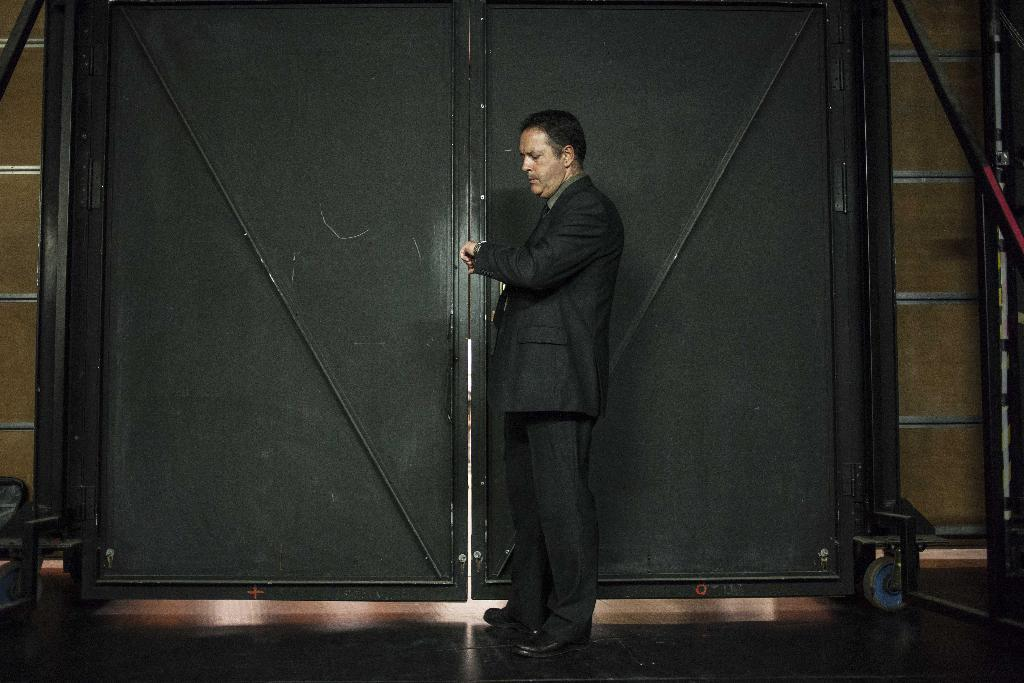What is the main subject of the image? There is a man standing in the image. What is the man standing on? There is a floor in the image. What can be seen in the background of the image? There is a black color gate and a wall in the image. What type of news can be heard coming from the yard in the image? There is no yard or news present in the image; it features a man standing with a black color gate and a wall in the background. What type of farm animals can be seen in the image? There are no farm animals present in the image. 